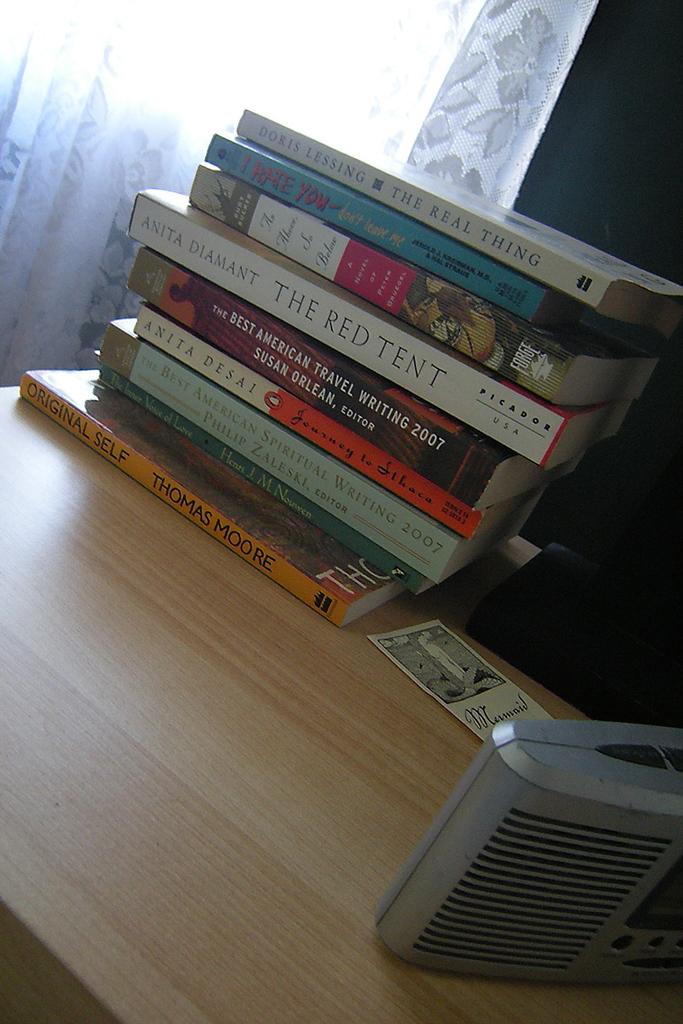What is the title of the fourth book from the top?
Make the answer very short. The red tent. 